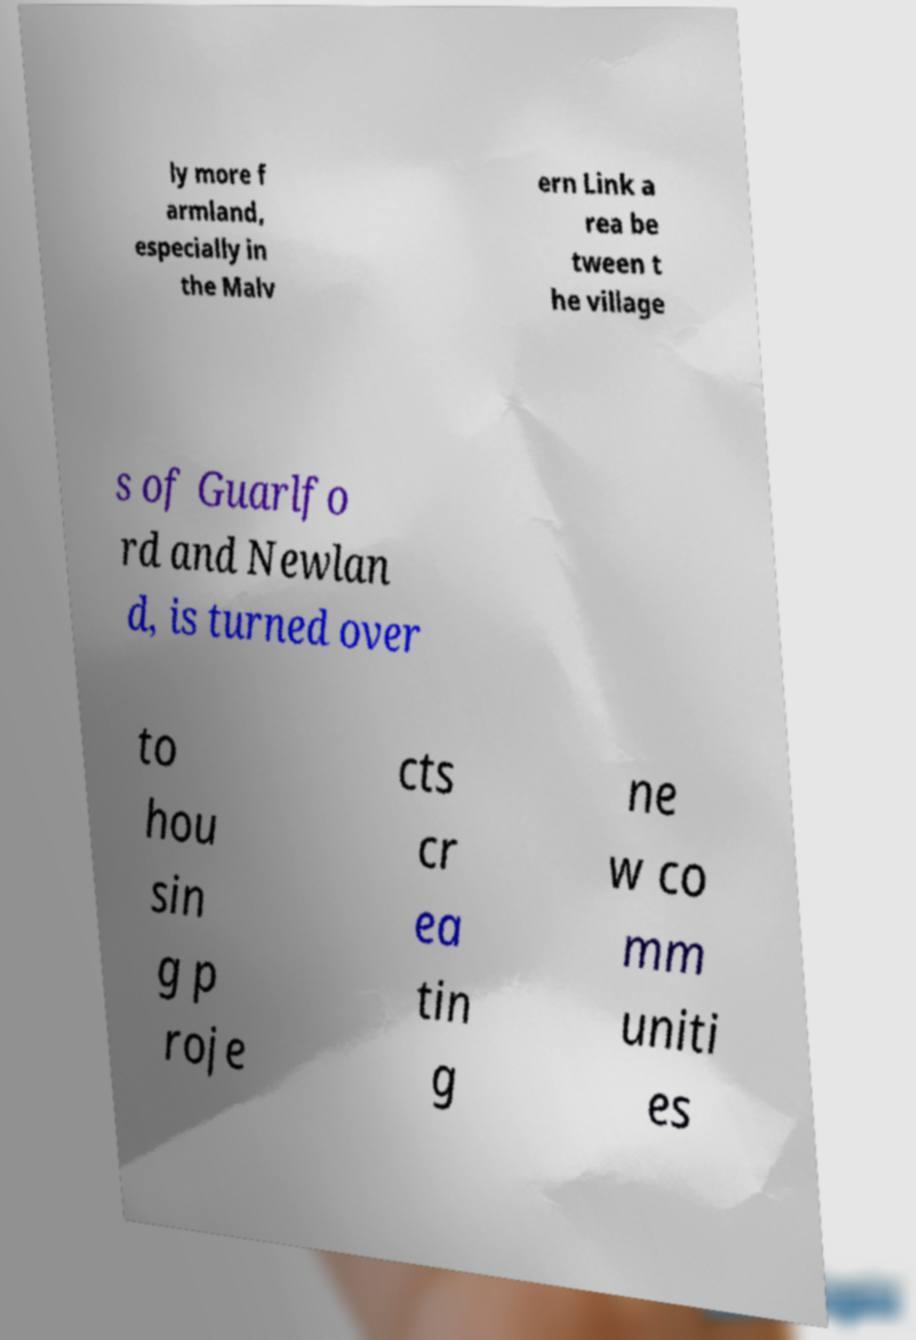What messages or text are displayed in this image? I need them in a readable, typed format. ly more f armland, especially in the Malv ern Link a rea be tween t he village s of Guarlfo rd and Newlan d, is turned over to hou sin g p roje cts cr ea tin g ne w co mm uniti es 